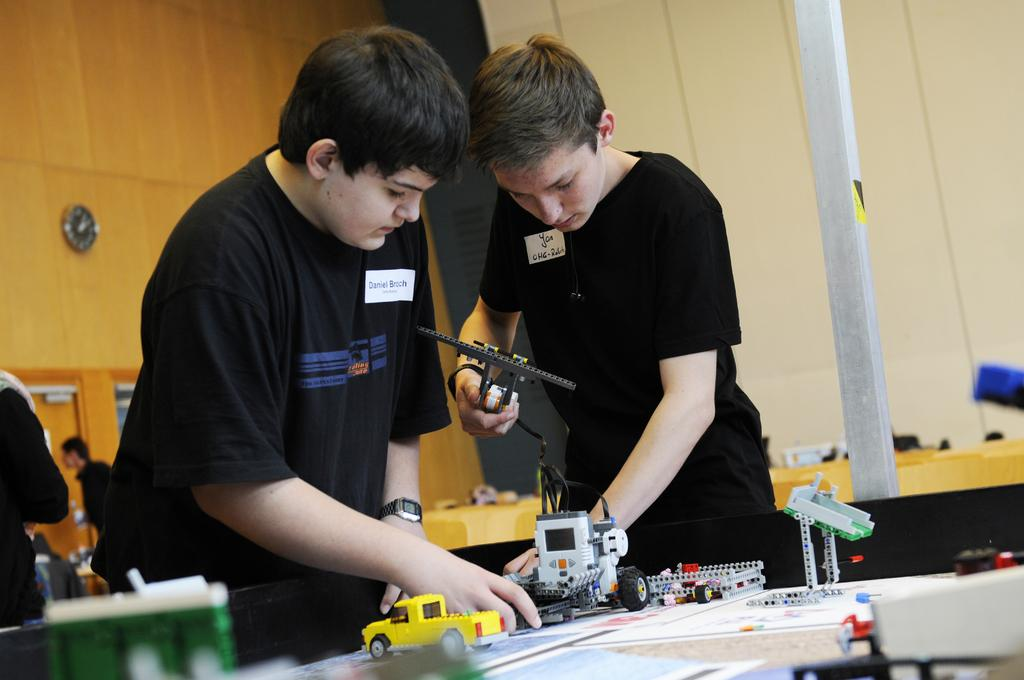Who is present in the image? There are young age children in the image. What are the children doing in the image? The children are operating toys. What type of flag is being waved by the children in the image? There is no flag present in the image; the children are operating toys. 